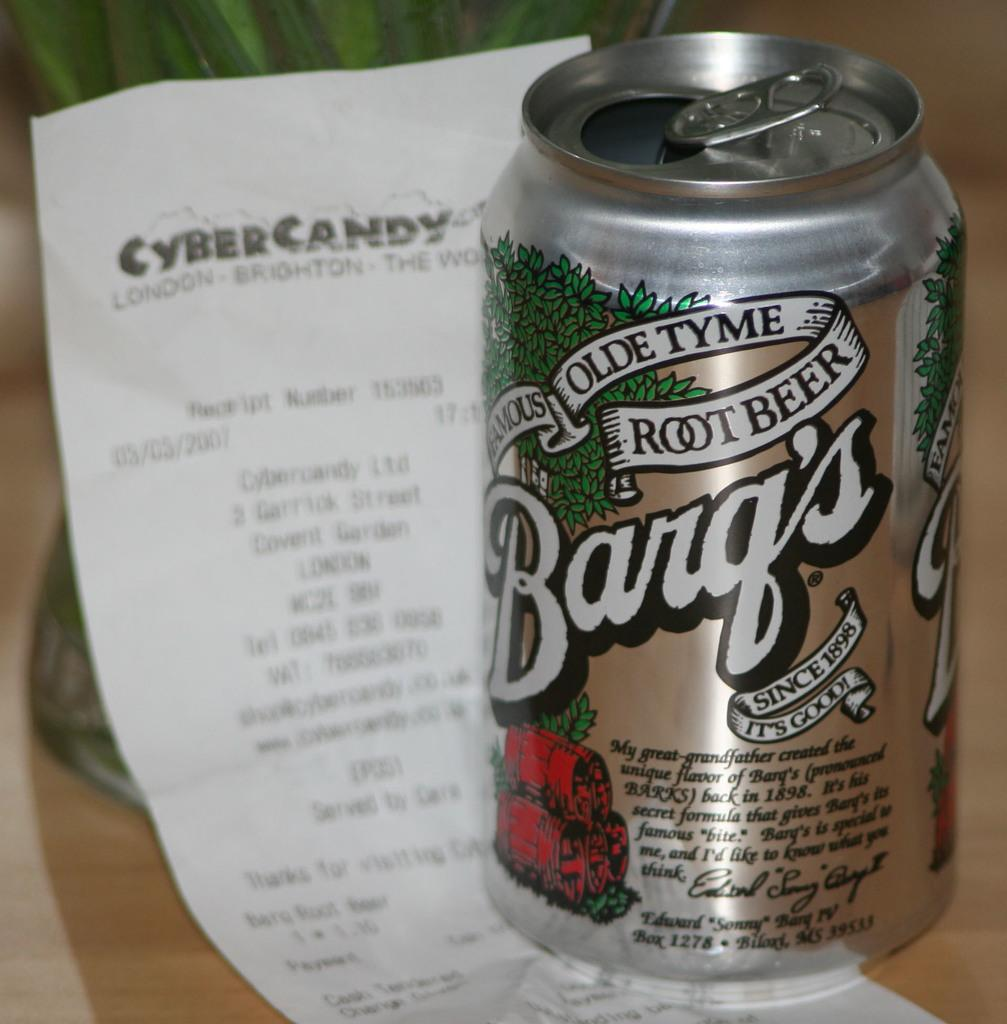Provide a one-sentence caption for the provided image. A silver can of Barq's Root Beer is in focus on a hard wooden surface and a receipt of some kind is in the background. 